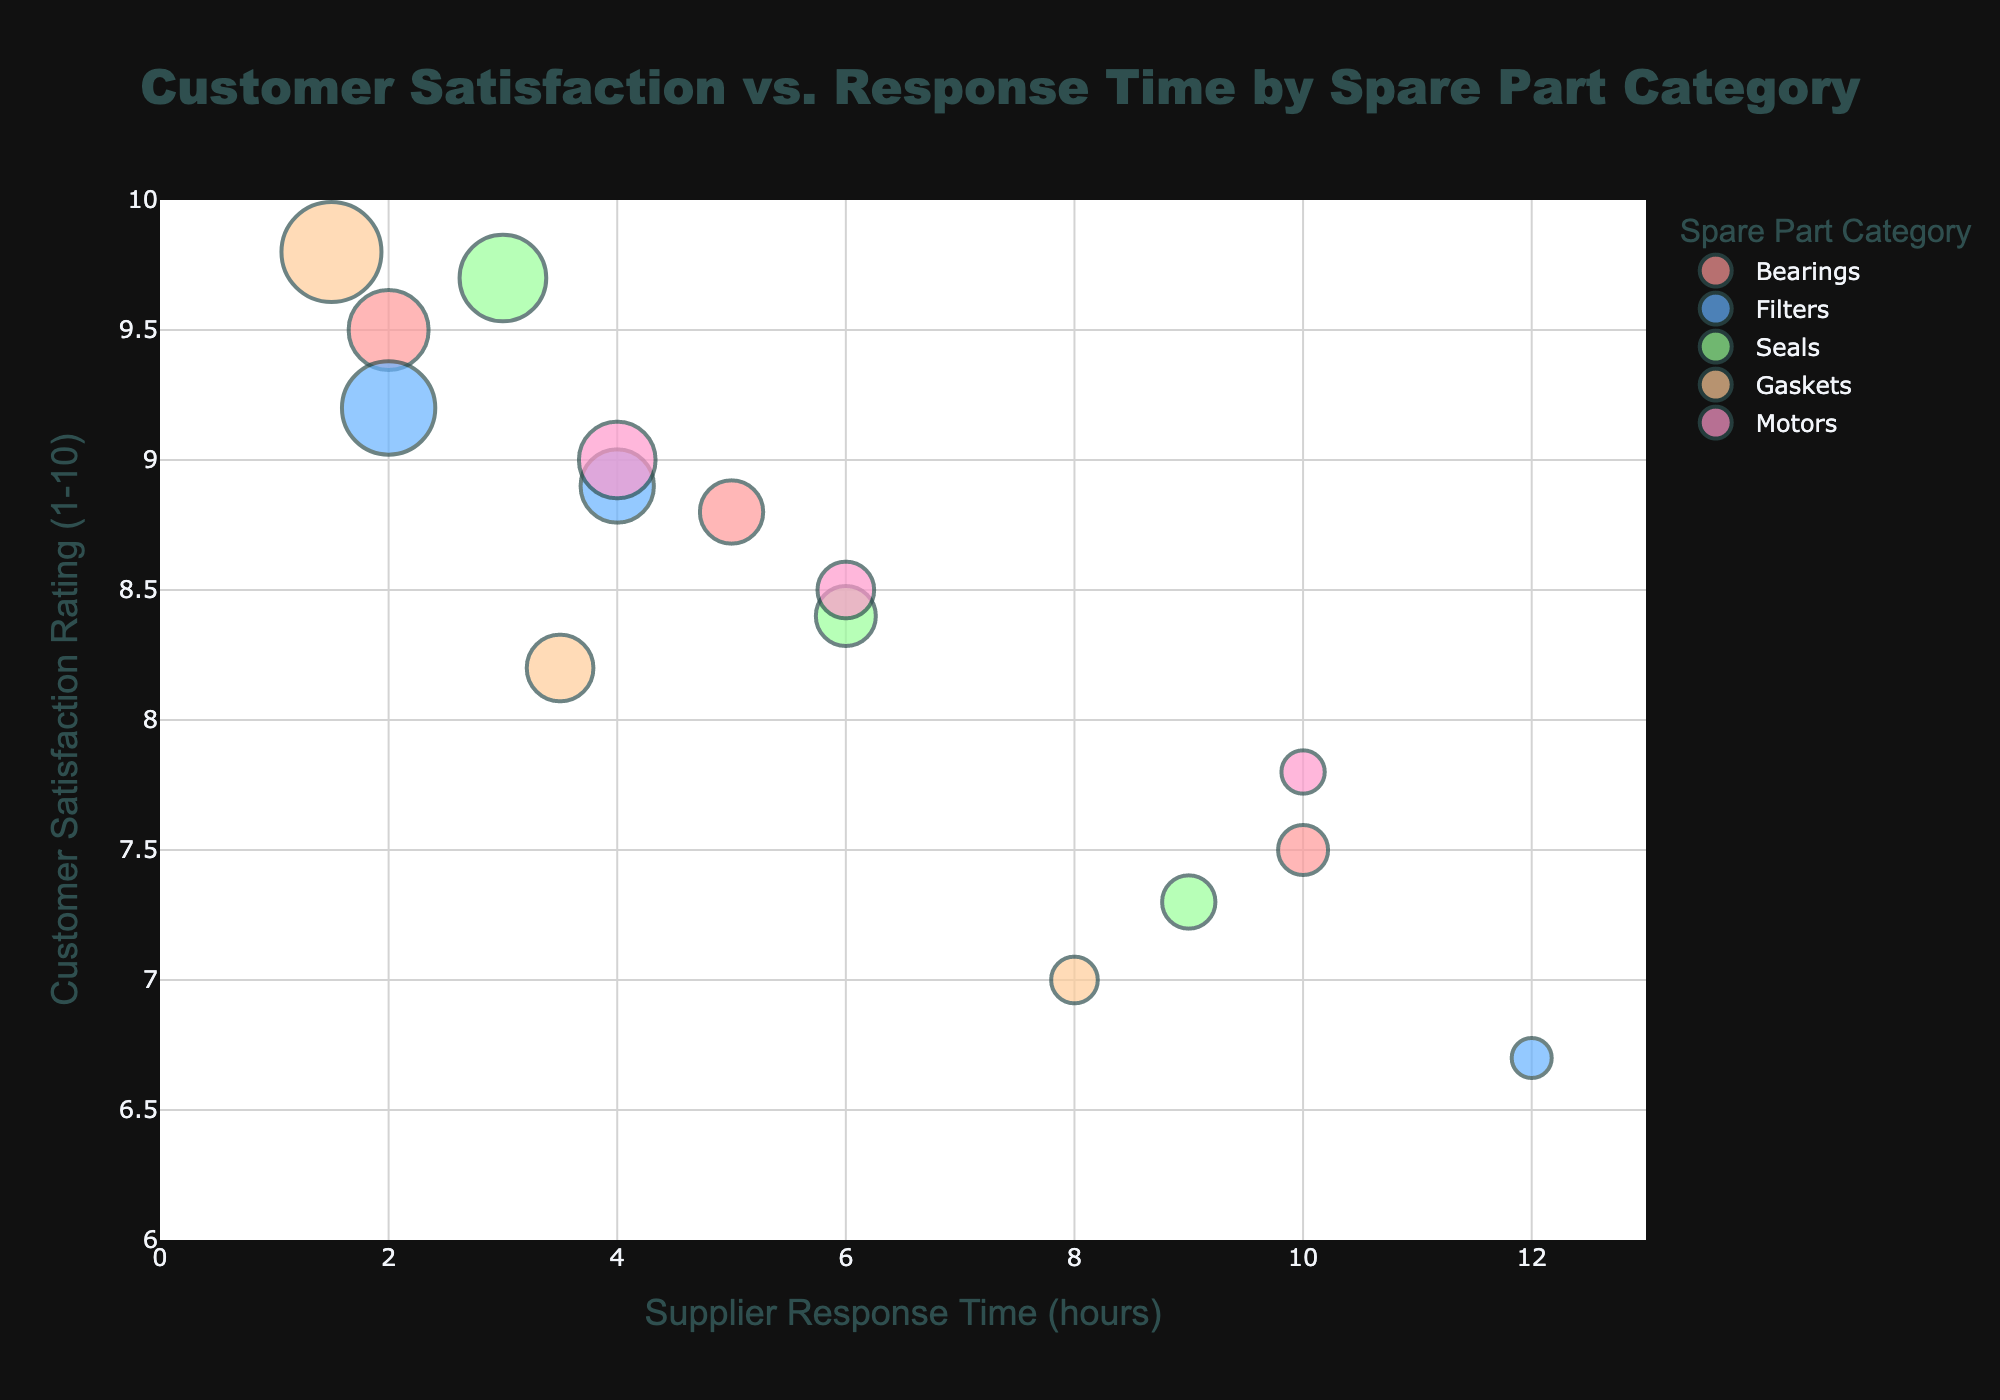What is the title of the bubble chart? The title is located at the top center of the chart and provides a summary of what the chart represents.
Answer: Customer Satisfaction vs. Response Time by Spare Part Category What are the x and y-axis titles? The titles for the x and y-axis are found at the bottom and left side of the chart respectively, describing what each axis represents.
Answer: Supplier Response Time (hours) and Customer Satisfaction Rating (1-10) How many unique spare part categories are displayed in the chart? There are five different colors representing each spare part category in the legend.
Answer: 5 Which spare part category has the highest customer satisfaction rating? The highest customer satisfaction rating corresponds to the highest point on the y-axis, which is 9.8 for Gaskets.
Answer: Gaskets What is the average customer satisfaction rating for Bearings? The ratings for Bearings are 9.5, 8.8, and 7.5. Adding these gives 9.5 + 8.8 + 7.5 = 25.8. Dividing by 3 gives 25.8/3 = 8.6.
Answer: 8.6 Which category has the shortest supplier response time? The shortest supplier response time corresponds to the leftmost point on the x-axis, which is 1.5 hours for Gaskets.
Answer: Gaskets How does the supplier response time affect customer satisfaction for Filters? By examining the data points for Filters, as the supplier response time increases from 2 to 12 hours, the customer satisfaction rating drops from 9.2 to 6.7, indicating a negative correlation.
Answer: Negative correlation Between Motors and Seals, which category has a higher customer satisfaction rating on average? The average rating for Motors (9.0, 8.5, 7.8) is (9.0+8.5+7.8)/3 = 8.43. The average rating for Seals (9.7, 8.4, 7.3) is (9.7+8.4+7.3)/3 = 8.47. Comparing these averages, Seals has a higher rating.
Answer: Seals Which spare part category has the largest volume of requests? The size of the bubbles represents the volume of requests, the largest bubble is in the Gaskets category with a volume of 150 requests.
Answer: Gaskets 